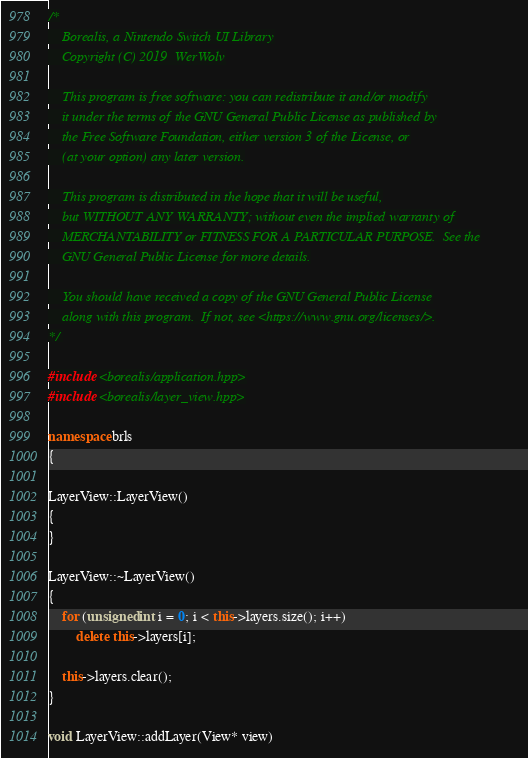Convert code to text. <code><loc_0><loc_0><loc_500><loc_500><_C++_>/*
    Borealis, a Nintendo Switch UI Library
    Copyright (C) 2019  WerWolv

    This program is free software: you can redistribute it and/or modify
    it under the terms of the GNU General Public License as published by
    the Free Software Foundation, either version 3 of the License, or
    (at your option) any later version.

    This program is distributed in the hope that it will be useful,
    but WITHOUT ANY WARRANTY; without even the implied warranty of
    MERCHANTABILITY or FITNESS FOR A PARTICULAR PURPOSE.  See the
    GNU General Public License for more details.

    You should have received a copy of the GNU General Public License
    along with this program.  If not, see <https://www.gnu.org/licenses/>.
*/

#include <borealis/application.hpp>
#include <borealis/layer_view.hpp>

namespace brls
{

LayerView::LayerView()
{
}

LayerView::~LayerView()
{
    for (unsigned int i = 0; i < this->layers.size(); i++)
        delete this->layers[i];

    this->layers.clear();
}

void LayerView::addLayer(View* view)</code> 